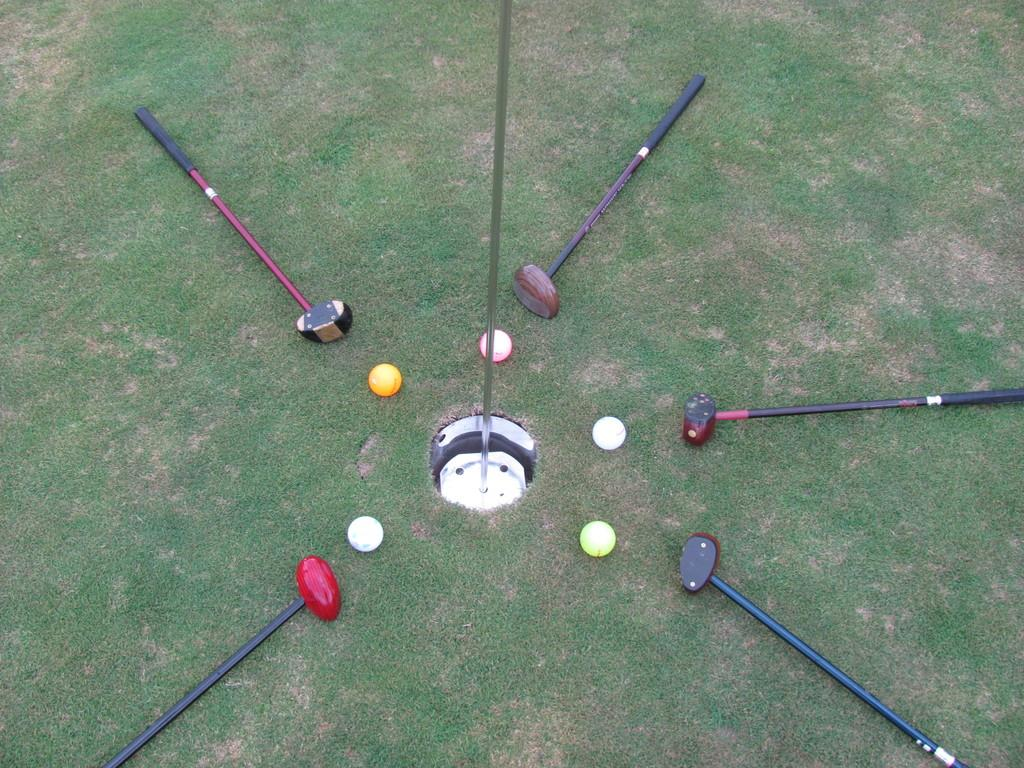What type of animals are in the image? There are bats in the image. What objects are also present in the image? There are balls in the image. Where are the bats and balls located? The bats and balls are on the grass. What other object can be seen in the image? There is an iron pole in the image. How does the knee of the bat affect its flight in the image? There are no knees mentioned in the image, as bats are winged mammals and do not have knees like humans. 